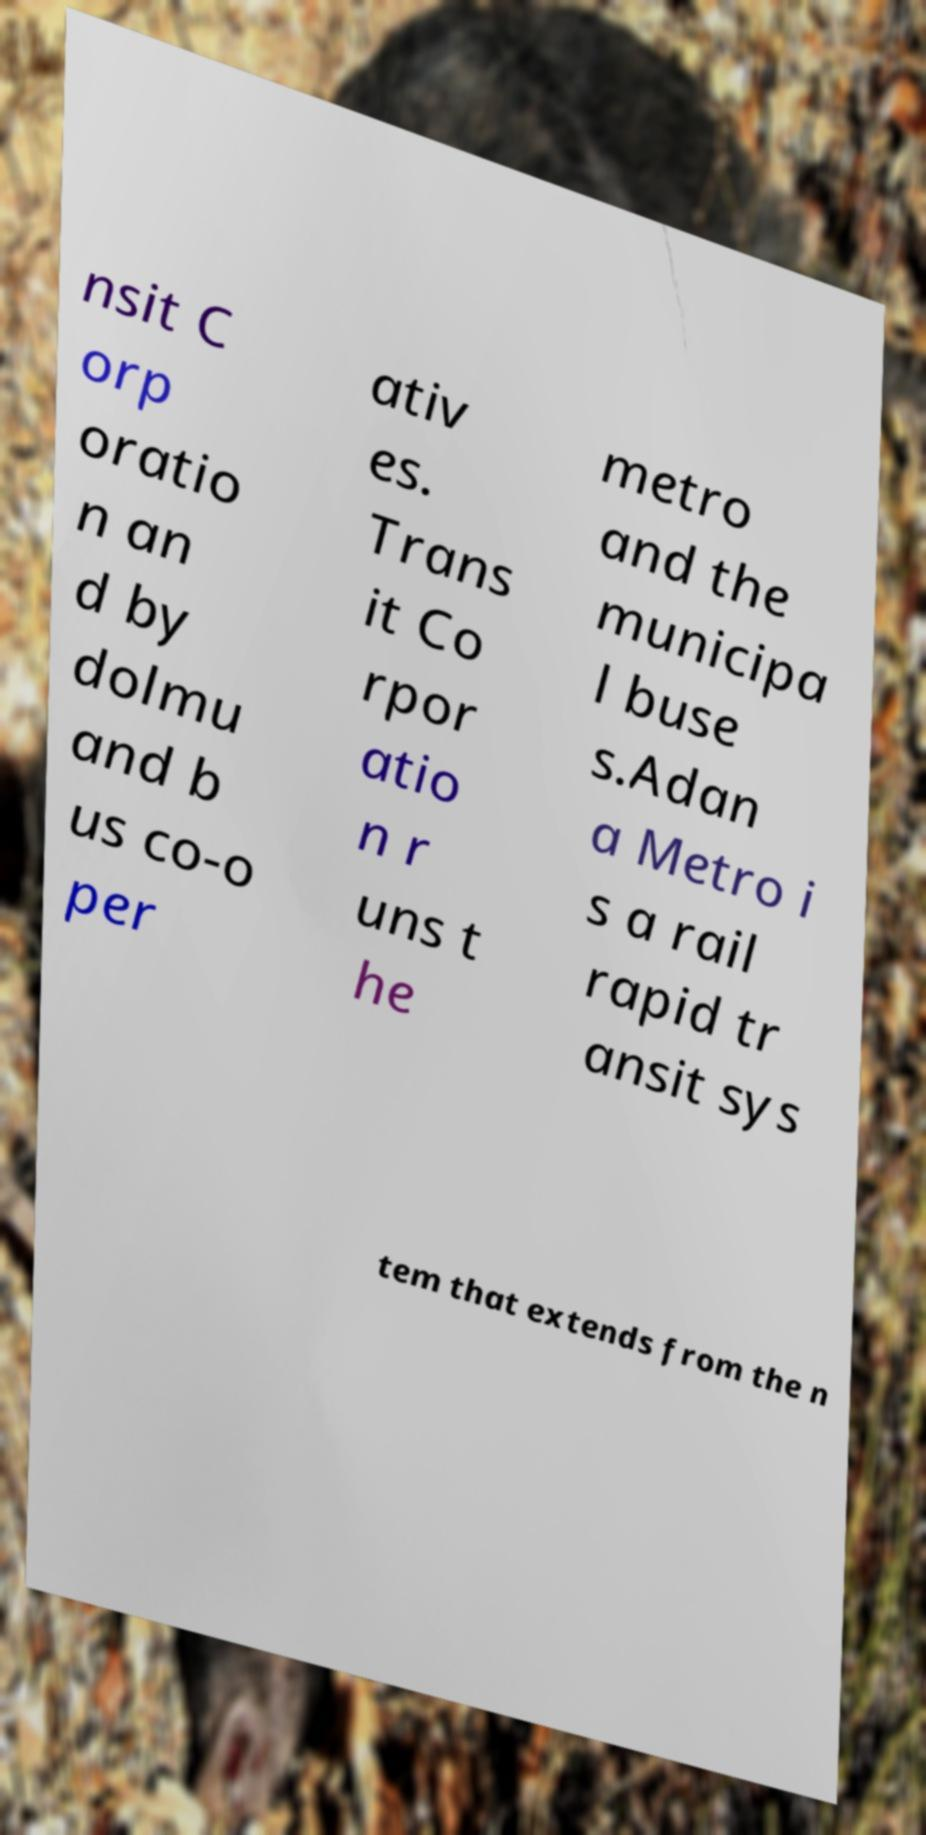Could you assist in decoding the text presented in this image and type it out clearly? nsit C orp oratio n an d by dolmu and b us co-o per ativ es. Trans it Co rpor atio n r uns t he metro and the municipa l buse s.Adan a Metro i s a rail rapid tr ansit sys tem that extends from the n 